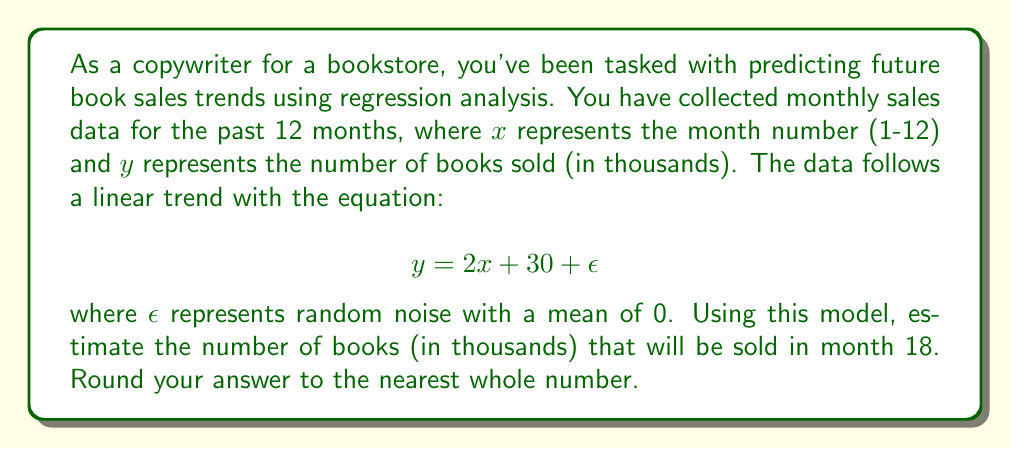Teach me how to tackle this problem. To solve this problem, we'll follow these steps:

1. Identify the linear regression equation:
   $$ y = 2x + 30 + \epsilon $$

2. Note that $\epsilon$ represents random noise with a mean of 0, so for prediction purposes, we can ignore it:
   $$ y = 2x + 30 $$

3. We need to predict sales for month 18, so substitute $x = 18$ into the equation:
   $$ y = 2(18) + 30 $$

4. Solve the equation:
   $$ y = 36 + 30 = 66 $$

5. Round to the nearest whole number:
   $$ y \approx 66 $$

Therefore, the predicted number of books sold in month 18 is 66 thousand.
Answer: 66 thousand books 